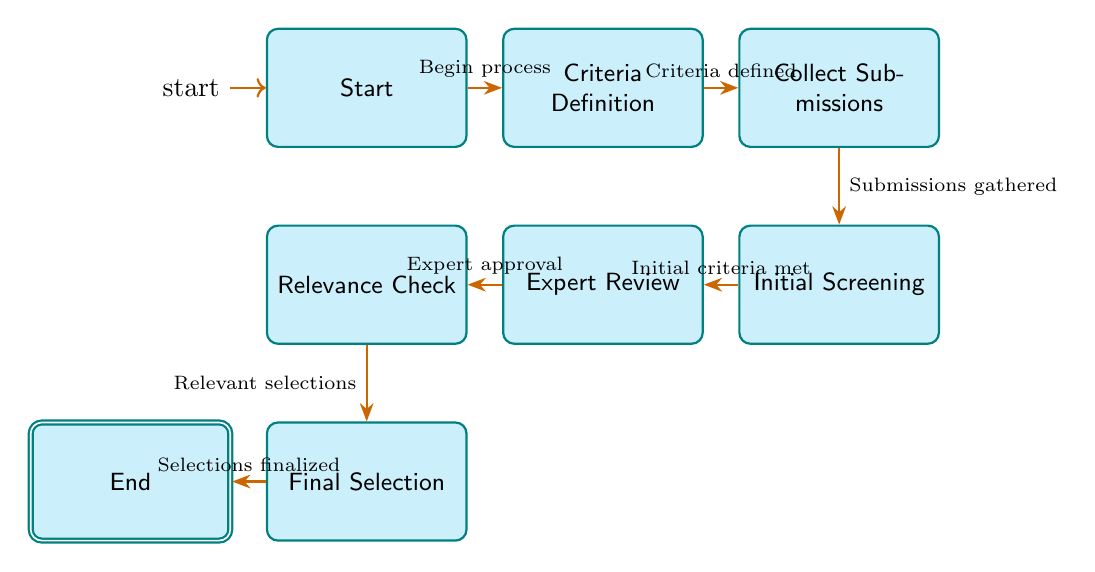What is the initial state of the diagram? The initial state is labeled "Start," and it is indicated as the first point in the selection process, marked as the entry point of the finite state machine.
Answer: Start How many nodes are present in the diagram? By counting each distinct state labeled from Start to End, we find a total of eight nodes which are the distinct states of the selection process.
Answer: 8 What is the final state of the diagram? The final state is labeled "End," and it represents the completion of the selection process for the folk songs and dances chosen for the festival.
Answer: End Which state follows "Expert Review"? Following "Expert Review," the next state is "Relevance Check," as indicated by the arrow pointing from Expert Review to Relevance Check.
Answer: Relevance Check What condition leads to the transition from "Initial Screening" to "Expert Review"? The transition occurs when the initial criteria are met, as stated in the diagram, linking the two states with an edge annotated accordingly.
Answer: Initial criteria met What is the last transition made in the process? The last transition made is from "Final Selection" to "End," completing the entire selection process once the final selections have been finalized.
Answer: Selections finalized Which state involves gathering folk song and dance submissions? The state that involves gathering submissions is "Collect Submissions," which directly follows the "Criteria Definition" state in the process flow.
Answer: Collect Submissions What process begins after defining criteria in the diagram? After defining criteria, the process that begins is the collection of submissions, as indicated by the arrow leading from "Criteria Definition" to "Collect Submissions."
Answer: Collect Submissions What is required for the transition from "Relevance Check" to "Final Selection"? The requirement for this transition is that the selections are relevant, highlighting the importance of cultural relevance in the selection process.
Answer: Relevant selections 